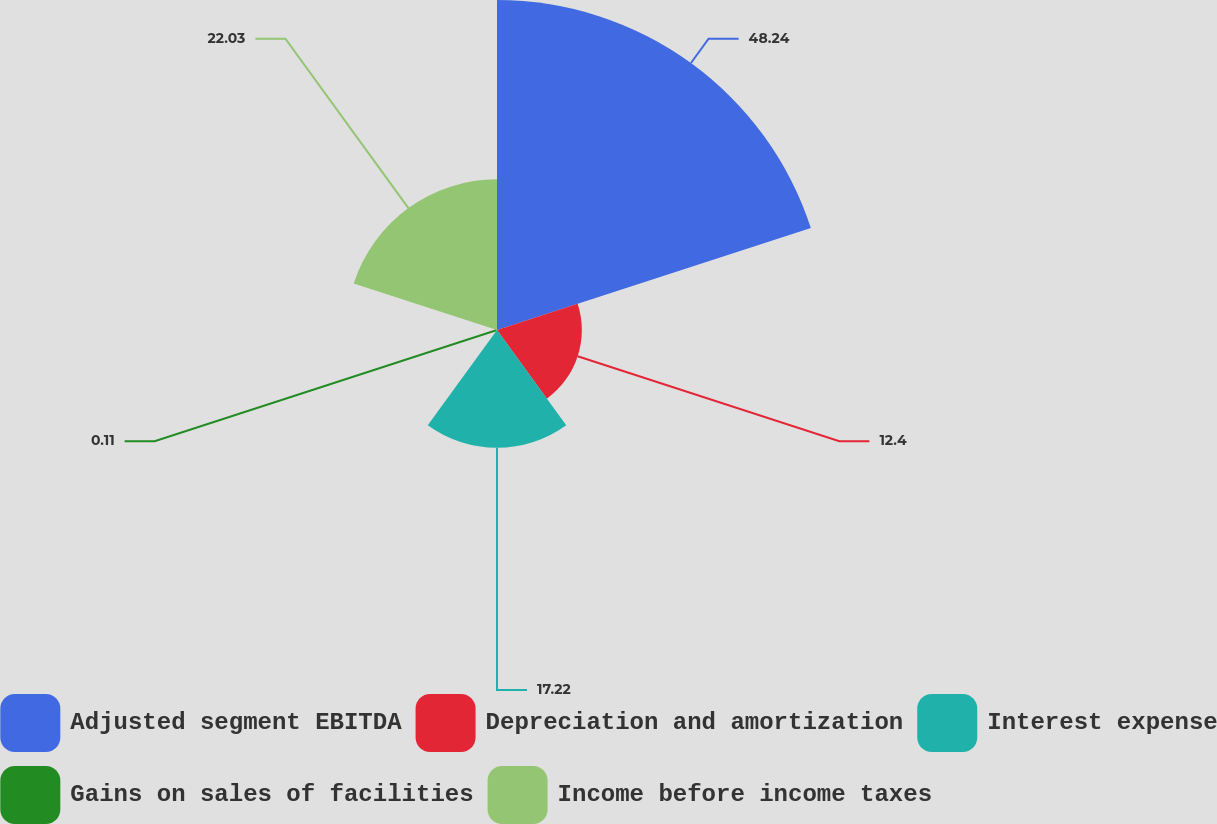Convert chart. <chart><loc_0><loc_0><loc_500><loc_500><pie_chart><fcel>Adjusted segment EBITDA<fcel>Depreciation and amortization<fcel>Interest expense<fcel>Gains on sales of facilities<fcel>Income before income taxes<nl><fcel>48.24%<fcel>12.4%<fcel>17.22%<fcel>0.11%<fcel>22.03%<nl></chart> 